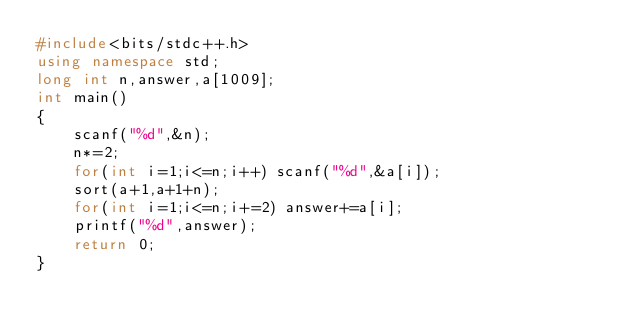Convert code to text. <code><loc_0><loc_0><loc_500><loc_500><_C++_>#include<bits/stdc++.h>
using namespace std;
long int n,answer,a[1009];
int main()
{
	scanf("%d",&n);
	n*=2;
	for(int i=1;i<=n;i++) scanf("%d",&a[i]);
	sort(a+1,a+1+n);
	for(int i=1;i<=n;i+=2) answer+=a[i];
	printf("%d",answer);
	return 0;
}</code> 